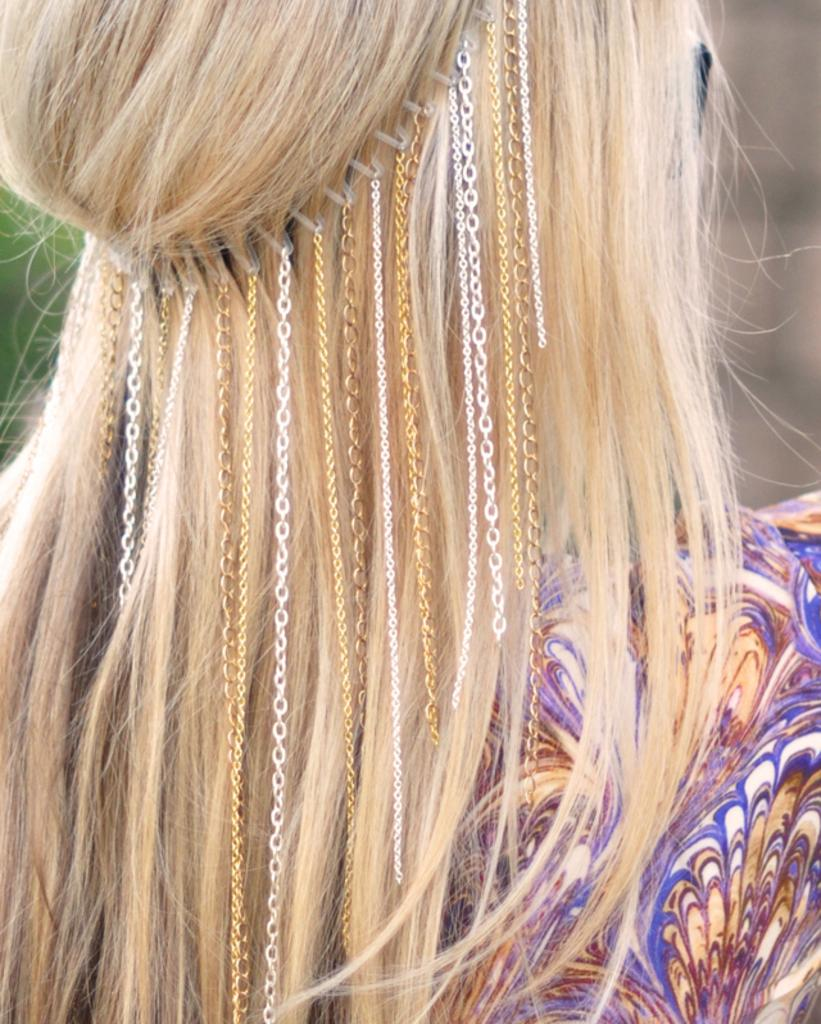What is the main subject of the image? There is a person in the center of the image. Can you describe the person's appearance? The person has a hair band on their hair. Are there any accessories attached to the hair band? Yes, a few chains are attached to the hair band. How many children are playing around the stove in the image? There are no children or stoves present in the image; it features a person with a hair band and attached chains. 